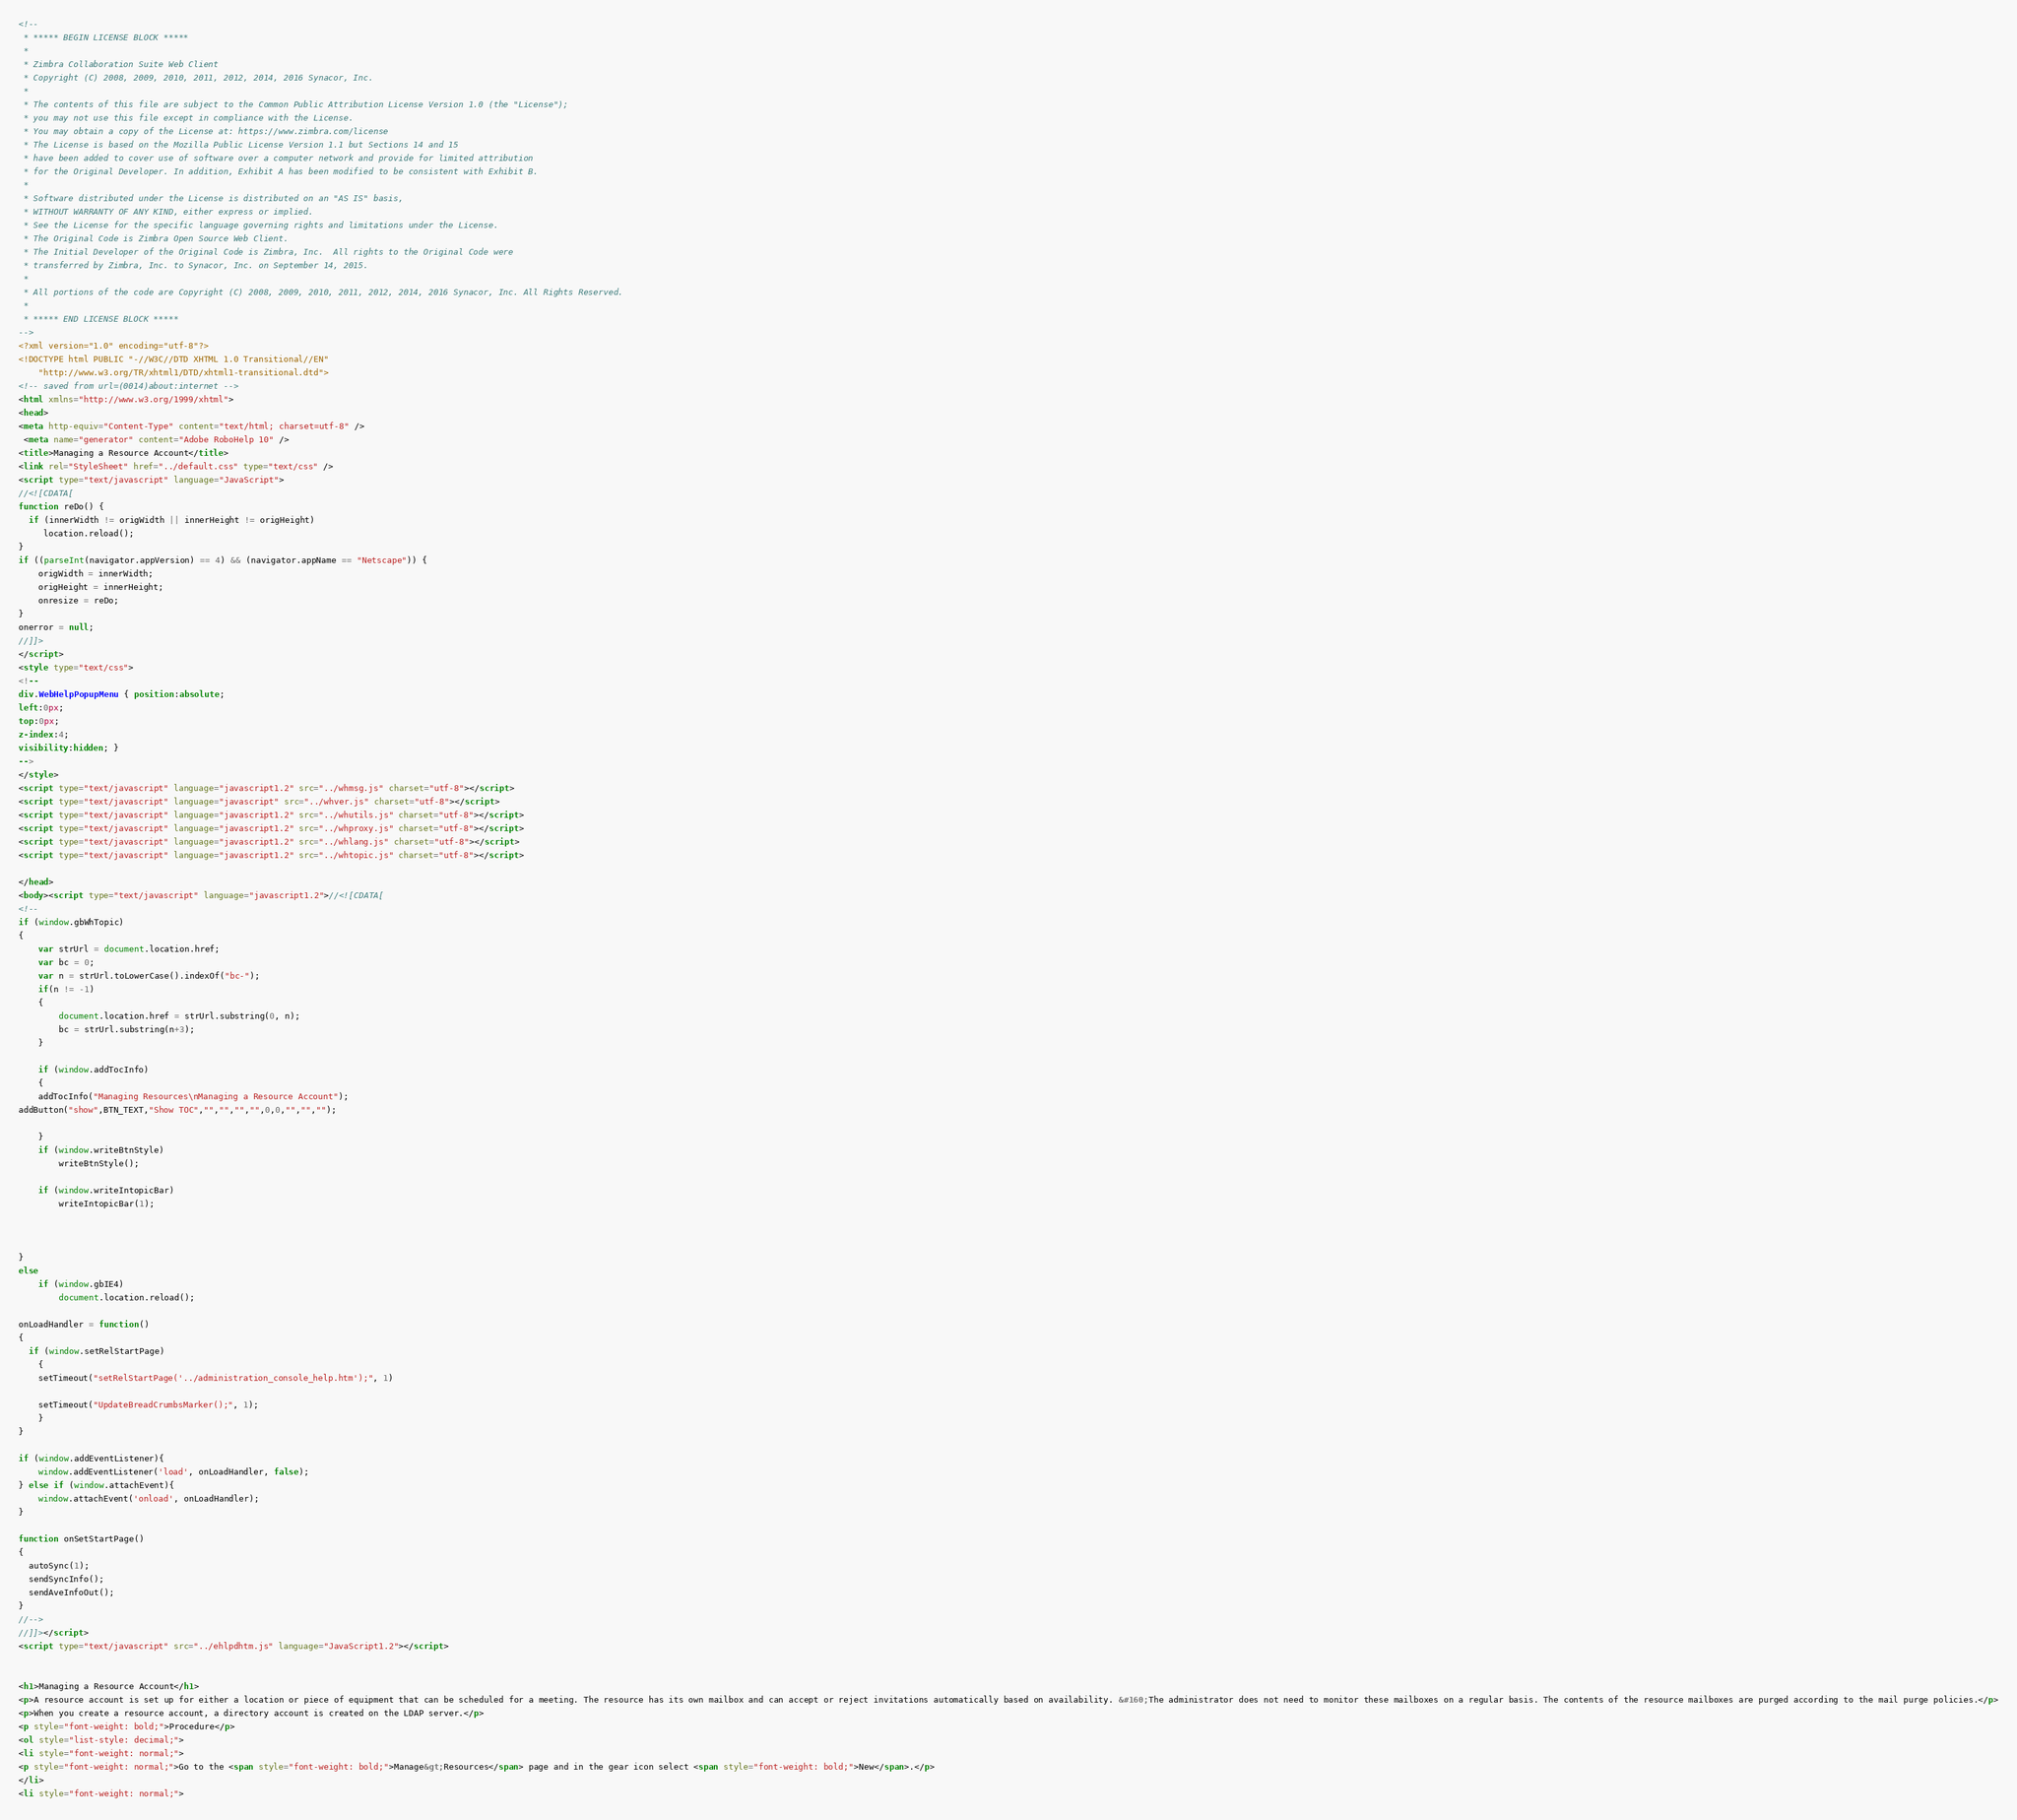Convert code to text. <code><loc_0><loc_0><loc_500><loc_500><_HTML_><!--
 * ***** BEGIN LICENSE BLOCK *****
 *
 * Zimbra Collaboration Suite Web Client
 * Copyright (C) 2008, 2009, 2010, 2011, 2012, 2014, 2016 Synacor, Inc.
 *
 * The contents of this file are subject to the Common Public Attribution License Version 1.0 (the "License");
 * you may not use this file except in compliance with the License.
 * You may obtain a copy of the License at: https://www.zimbra.com/license
 * The License is based on the Mozilla Public License Version 1.1 but Sections 14 and 15
 * have been added to cover use of software over a computer network and provide for limited attribution
 * for the Original Developer. In addition, Exhibit A has been modified to be consistent with Exhibit B.
 *
 * Software distributed under the License is distributed on an "AS IS" basis,
 * WITHOUT WARRANTY OF ANY KIND, either express or implied.
 * See the License for the specific language governing rights and limitations under the License.
 * The Original Code is Zimbra Open Source Web Client.
 * The Initial Developer of the Original Code is Zimbra, Inc.  All rights to the Original Code were
 * transferred by Zimbra, Inc. to Synacor, Inc. on September 14, 2015.
 *
 * All portions of the code are Copyright (C) 2008, 2009, 2010, 2011, 2012, 2014, 2016 Synacor, Inc. All Rights Reserved.
 *
 * ***** END LICENSE BLOCK *****
-->
<?xml version="1.0" encoding="utf-8"?>
<!DOCTYPE html PUBLIC "-//W3C//DTD XHTML 1.0 Transitional//EN"
    "http://www.w3.org/TR/xhtml1/DTD/xhtml1-transitional.dtd">
<!-- saved from url=(0014)about:internet -->
<html xmlns="http://www.w3.org/1999/xhtml">
<head>
<meta http-equiv="Content-Type" content="text/html; charset=utf-8" />
 <meta name="generator" content="Adobe RoboHelp 10" />
<title>Managing a Resource Account</title>
<link rel="StyleSheet" href="../default.css" type="text/css" />
<script type="text/javascript" language="JavaScript">
//<![CDATA[
function reDo() {
  if (innerWidth != origWidth || innerHeight != origHeight)
     location.reload();
}
if ((parseInt(navigator.appVersion) == 4) && (navigator.appName == "Netscape")) {
	origWidth = innerWidth;
	origHeight = innerHeight;
	onresize = reDo;
}
onerror = null; 
//]]>
</script>
<style type="text/css">
<!--
div.WebHelpPopupMenu { position:absolute;
left:0px;
top:0px;
z-index:4;
visibility:hidden; }
-->
</style>
<script type="text/javascript" language="javascript1.2" src="../whmsg.js" charset="utf-8"></script>
<script type="text/javascript" language="javascript" src="../whver.js" charset="utf-8"></script>
<script type="text/javascript" language="javascript1.2" src="../whutils.js" charset="utf-8"></script>
<script type="text/javascript" language="javascript1.2" src="../whproxy.js" charset="utf-8"></script>
<script type="text/javascript" language="javascript1.2" src="../whlang.js" charset="utf-8"></script>
<script type="text/javascript" language="javascript1.2" src="../whtopic.js" charset="utf-8"></script>

</head>
<body><script type="text/javascript" language="javascript1.2">//<![CDATA[
<!--
if (window.gbWhTopic)
{
	var strUrl = document.location.href;
	var bc = 0;
	var n = strUrl.toLowerCase().indexOf("bc-");
	if(n != -1)
	{
		document.location.href = strUrl.substring(0, n);
		bc = strUrl.substring(n+3);
	}

	if (window.addTocInfo)
	{
	addTocInfo("Managing Resources\nManaging a Resource Account");
addButton("show",BTN_TEXT,"Show TOC","","","","",0,0,"","","");

	}
	if (window.writeBtnStyle)
		writeBtnStyle();

	if (window.writeIntopicBar)
		writeIntopicBar(1);

	
	
}
else
	if (window.gbIE4)
		document.location.reload();

onLoadHandler = function()
{
  if (window.setRelStartPage)
	{
	setTimeout("setRelStartPage('../administration_console_help.htm');", 1)

    setTimeout("UpdateBreadCrumbsMarker();", 1);
	}
}

if (window.addEventListener){  
	window.addEventListener('load', onLoadHandler, false);   
} else if (window.attachEvent){  
	window.attachEvent('onload', onLoadHandler);  
}

function onSetStartPage()
{
  autoSync(1);
  sendSyncInfo();
  sendAveInfoOut();
}
//-->
//]]></script>
<script type="text/javascript" src="../ehlpdhtm.js" language="JavaScript1.2"></script>


<h1>Managing a Resource Account</h1>
<p>A resource account is set up for either a location or piece of equipment that can be scheduled for a meeting. The resource has its own mailbox and can accept or reject invitations automatically based on availability. &#160;The administrator does not need to monitor these mailboxes on a regular basis. The contents of the resource mailboxes are purged according to the mail purge policies.</p>
<p>When you create a resource account, a directory account is created on the LDAP server.</p>
<p style="font-weight: bold;">Procedure</p>
<ol style="list-style: decimal;">
<li style="font-weight: normal;">
<p style="font-weight: normal;">Go to the <span style="font-weight: bold;">Manage&gt;Resources</span> page and in the gear icon select <span style="font-weight: bold;">New</span>.</p>
</li>
<li style="font-weight: normal;"></code> 